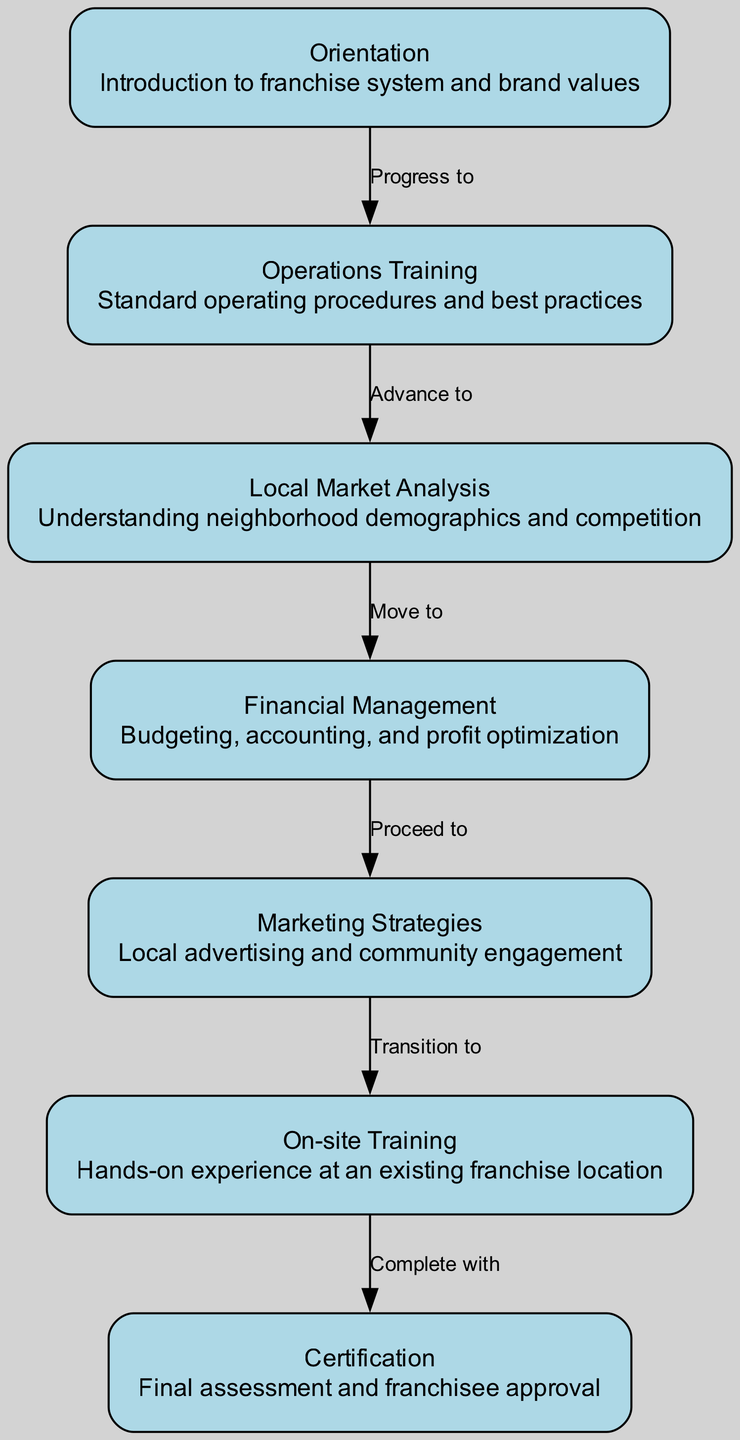What is the first step in the franchisee training program? The first node in the diagram is "Orientation," which represents the initial stage of the training program.
Answer: Orientation How many nodes are in the training program structure? By counting the nodes listed in the data, there are 7 distinct nodes in the diagram.
Answer: 7 What is the relationship between "Operations Training" and "Local Market Analysis"? The diagram indicates a directed flow from "Operations Training" to "Local Market Analysis," labeled as "Advance to," which shows that after operations training, the next step is local market analysis.
Answer: Advance to What is the last stage before certification in the training program? The penultimate node before reaching the Certification stage is "On-site Training," as indicated by the flow in the diagram.
Answer: On-site Training Which two nodes are connected by the label "Transition to"? According to the diagram, "Marketing Strategies" and "On-site Training" are connected by the label "Transition to," illustrating the step from marketing strategies to on-site training.
Answer: Marketing Strategies and On-site Training What does the "Financial Management" node focus on in the training program? The description of the "Financial Management" node specifies that it covers budgeting, accounting, and profit optimization, defining its focus in the training program.
Answer: Budgeting, accounting, and profit optimization After "Local Market Analysis," what is the next step in the training program? The directed edge from "Local Market Analysis" leads to "Financial Management," indicating that the next step after local market analysis is financial management.
Answer: Financial Management What is the common theme connecting all the nodes? All nodes represent stages of the franchisee training process, indicating a structured progression through necessary skills and knowledge for franchise owners.
Answer: Franchisee training process Which node emphasizes learning from real-life experience? The "On-site Training" node specifies hands-on experience at an existing franchise location, emphasizing practical learning.
Answer: On-site Training 